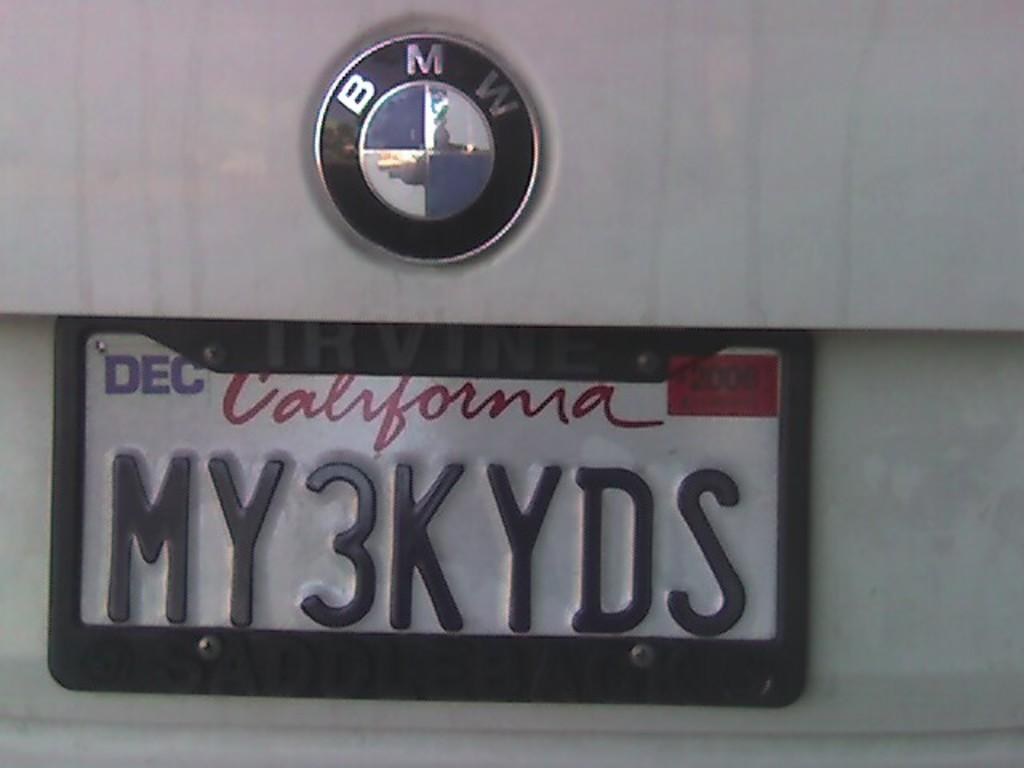<image>
Summarize the visual content of the image. White California license plate which says MY3KYDS on it. 